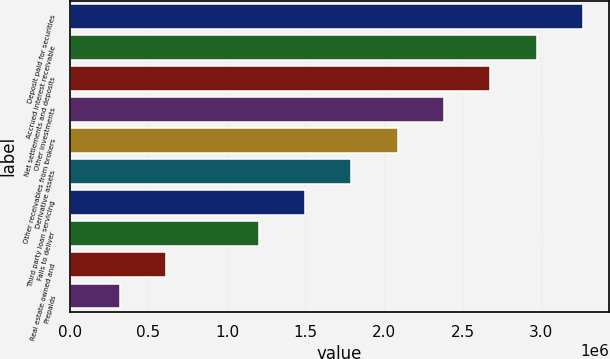Convert chart. <chart><loc_0><loc_0><loc_500><loc_500><bar_chart><fcel>Deposit paid for securities<fcel>Accrued interest receivable<fcel>Net settlements and deposits<fcel>Other investments<fcel>Other receivables from brokers<fcel>Derivative assets<fcel>Third party loan servicing<fcel>Fails to deliver<fcel>Real estate owned and<fcel>Prepaids<nl><fcel>3.26686e+06<fcel>2.97185e+06<fcel>2.67684e+06<fcel>2.38183e+06<fcel>2.08682e+06<fcel>1.79181e+06<fcel>1.4968e+06<fcel>1.20179e+06<fcel>611771<fcel>316761<nl></chart> 